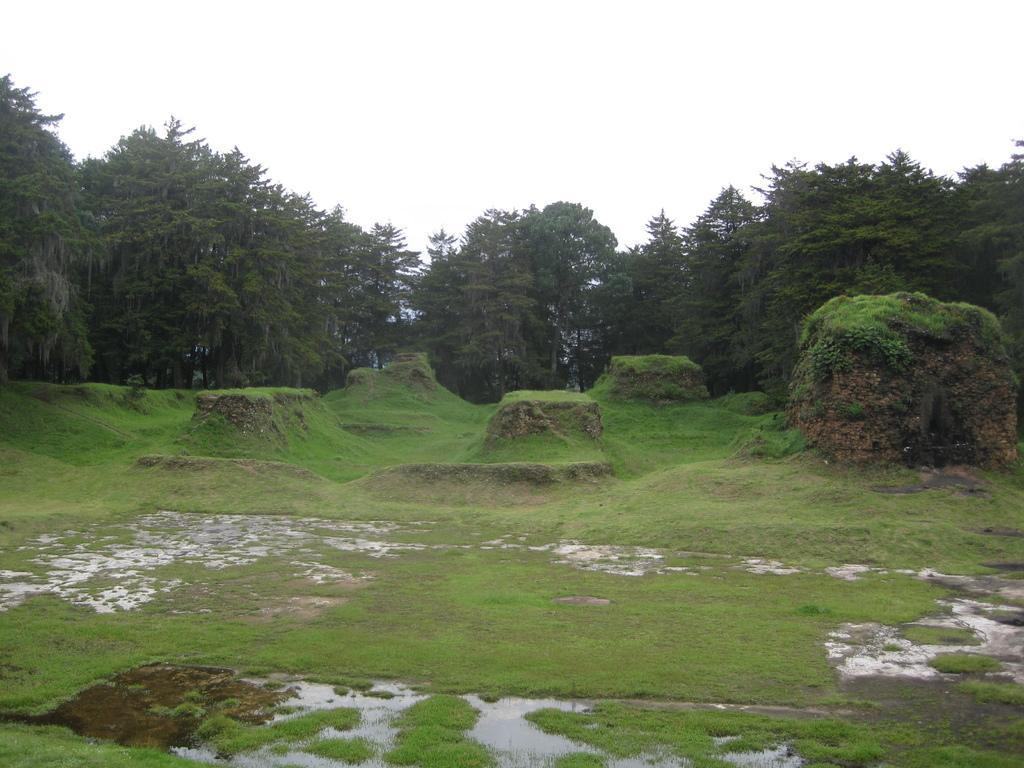Could you give a brief overview of what you see in this image? This picture is clicked outside. In the foreground we can see the green grass and some other objects and we can see the trees. In the background there is a sky. 